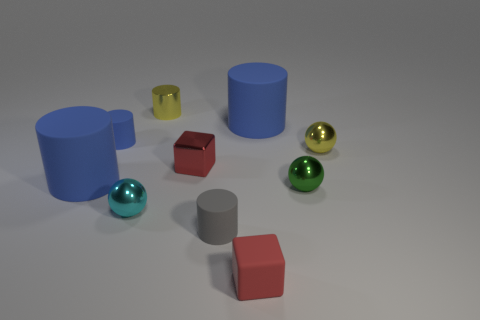What material is the other block that is the same color as the small metallic cube?
Ensure brevity in your answer.  Rubber. What number of things are large blue matte things or yellow matte things?
Your answer should be compact. 2. Are the cube that is on the right side of the tiny shiny cube and the tiny gray object made of the same material?
Your answer should be very brief. Yes. What number of objects are either big cylinders on the right side of the small shiny cylinder or metallic cylinders?
Your answer should be compact. 2. What is the color of the small cube that is the same material as the small gray cylinder?
Your answer should be compact. Red. Is there another object that has the same size as the red metal object?
Provide a short and direct response. Yes. There is a tiny matte thing behind the yellow shiny sphere; is its color the same as the small rubber cube?
Keep it short and to the point. No. There is a small matte thing that is both right of the red metallic thing and behind the tiny red matte block; what is its color?
Give a very brief answer. Gray. What shape is the cyan thing that is the same size as the green metal object?
Your answer should be compact. Sphere. Are there any tiny blue metal things of the same shape as the red rubber object?
Offer a very short reply. No. 